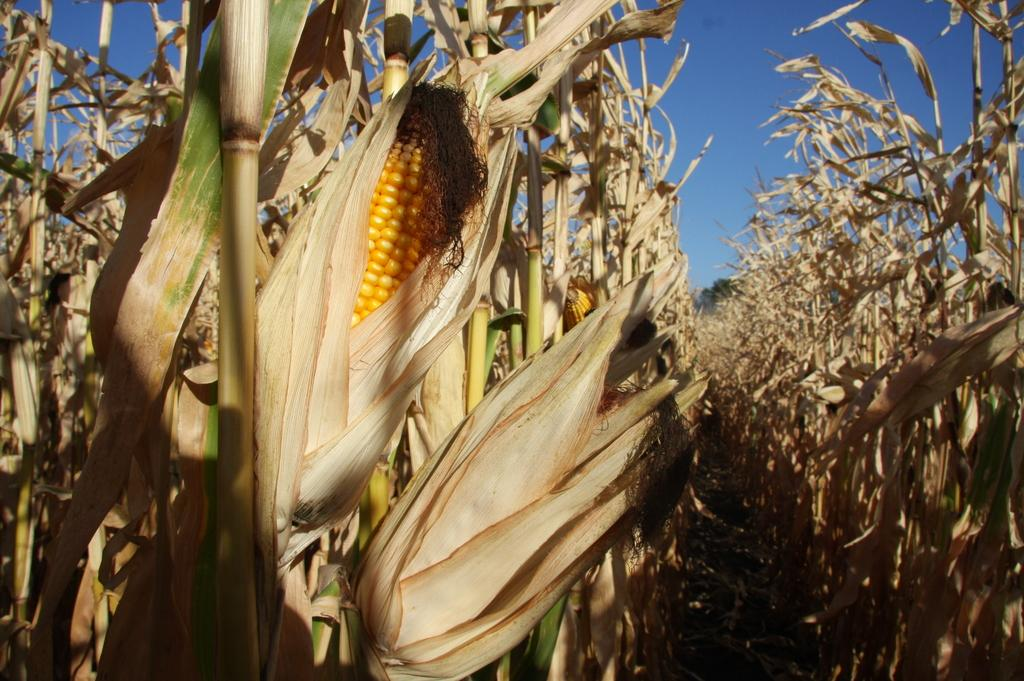What is the main subject of the image? The main subject of the image is a corn field. How many corn plants can be seen in the field? There are many corn plants in the field. What is the condition of most of the corn plants? Most of the corn plants are dried up. What can be seen in the background of the image? The sky is visible in the background of the image. Can you describe the experience of the person walking through the corn field in the image? There is no person present in the image, so it is not possible to describe their experience walking through the corn field. 